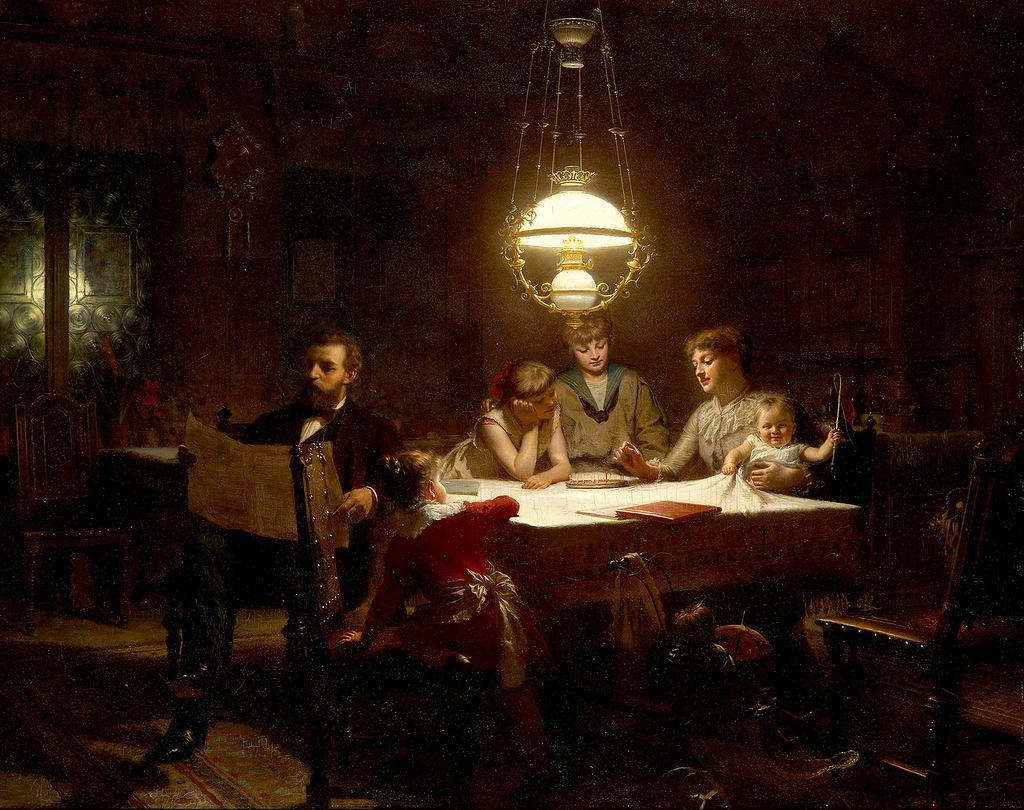Describe this image in one or two sentences. This image is a painting where it has a light on the top and table in the middle, chairs are placed around the table. People are sitting on the chair around the table. There is a door on the left side. On the table there is book, paper and cloth. A man who is sitting on the left side is holding paper. 